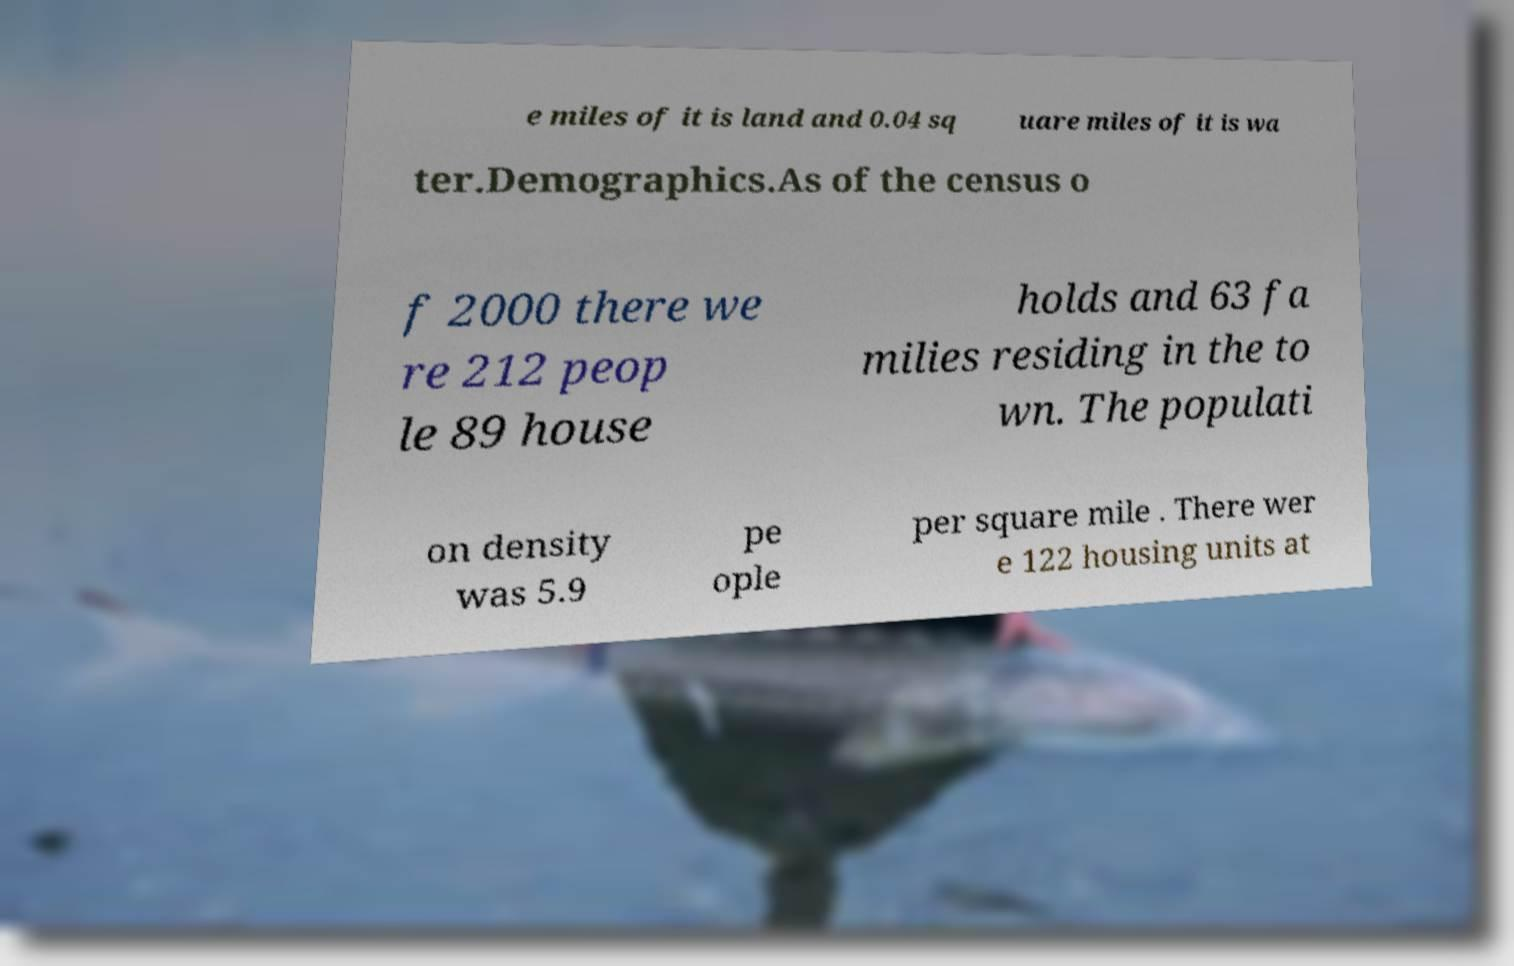Can you accurately transcribe the text from the provided image for me? e miles of it is land and 0.04 sq uare miles of it is wa ter.Demographics.As of the census o f 2000 there we re 212 peop le 89 house holds and 63 fa milies residing in the to wn. The populati on density was 5.9 pe ople per square mile . There wer e 122 housing units at 